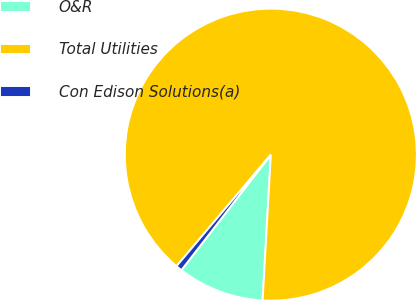Convert chart. <chart><loc_0><loc_0><loc_500><loc_500><pie_chart><fcel>O&R<fcel>Total Utilities<fcel>Con Edison Solutions(a)<nl><fcel>9.59%<fcel>89.73%<fcel>0.69%<nl></chart> 